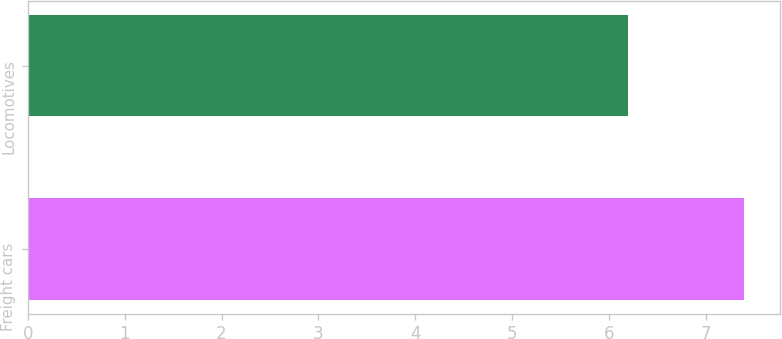Convert chart. <chart><loc_0><loc_0><loc_500><loc_500><bar_chart><fcel>Freight cars<fcel>Locomotives<nl><fcel>7.4<fcel>6.2<nl></chart> 